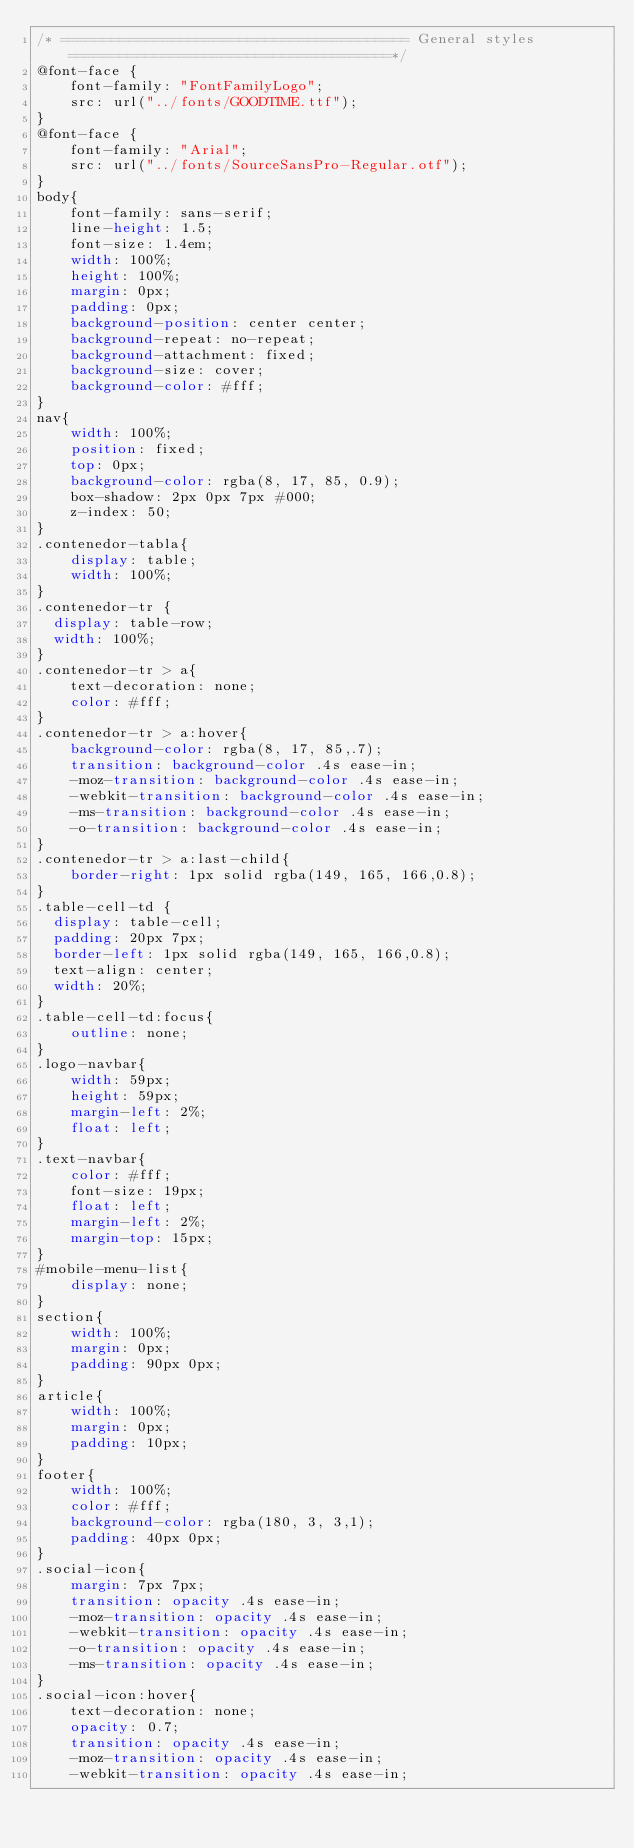<code> <loc_0><loc_0><loc_500><loc_500><_CSS_>/* ========================================= General styles ======================================*/
@font-face { 
    font-family: "FontFamilyLogo";
    src: url("../fonts/GOODTIME.ttf");
}
@font-face { 
    font-family: "Arial";
    src: url("../fonts/SourceSansPro-Regular.otf");
}
body{
    font-family: sans-serif;
    line-height: 1.5;
    font-size: 1.4em;
    width: 100%;
    height: 100%;
    margin: 0px;
    padding: 0px;
    background-position: center center;
    background-repeat: no-repeat;
    background-attachment: fixed;
    background-size: cover;
    background-color: #fff;
}
nav{
    width: 100%;
    position: fixed;
    top: 0px;
    background-color: rgba(8, 17, 85, 0.9);
    box-shadow: 2px 0px 7px #000;
	z-index: 50;
}
.contenedor-tabla{
    display: table;
    width: 100%;
}
.contenedor-tr {
  display: table-row;
  width: 100%;
}
.contenedor-tr > a{
	text-decoration: none;
	color: #fff;
}
.contenedor-tr > a:hover{
	background-color: rgba(8, 17, 85,.7);
    transition: background-color .4s ease-in;
    -moz-transition: background-color .4s ease-in;
    -webkit-transition: background-color .4s ease-in;
    -ms-transition: background-color .4s ease-in;
    -o-transition: background-color .4s ease-in;
}
.contenedor-tr > a:last-child{
	border-right: 1px solid rgba(149, 165, 166,0.8);
}
.table-cell-td {
  display: table-cell;
  padding: 20px 7px;
  border-left: 1px solid rgba(149, 165, 166,0.8);
  text-align: center;
  width: 20%;
}
.table-cell-td:focus{
	outline: none;
}
.logo-navbar{
    width: 59px;
    height: 59px;
    margin-left: 2%;
    float: left;
}
.text-navbar{
    color: #fff;
    font-size: 19px;
    float: left;
    margin-left: 2%;
    margin-top: 15px;
}
#mobile-menu-list{
	display: none;
}
section{
    width: 100%;
    margin: 0px;
    padding: 90px 0px;
}
article{
    width: 100%;
    margin: 0px;
    padding: 10px;
}
footer{
    width: 100%;
    color: #fff;
    background-color: rgba(180, 3, 3,1);
    padding: 40px 0px;
}
.social-icon{
    margin: 7px 7px;
    transition: opacity .4s ease-in;
    -moz-transition: opacity .4s ease-in;
    -webkit-transition: opacity .4s ease-in;
    -o-transition: opacity .4s ease-in;
    -ms-transition: opacity .4s ease-in;
}
.social-icon:hover{
    text-decoration: none; 
    opacity: 0.7;
    transition: opacity .4s ease-in;
    -moz-transition: opacity .4s ease-in;
    -webkit-transition: opacity .4s ease-in;</code> 